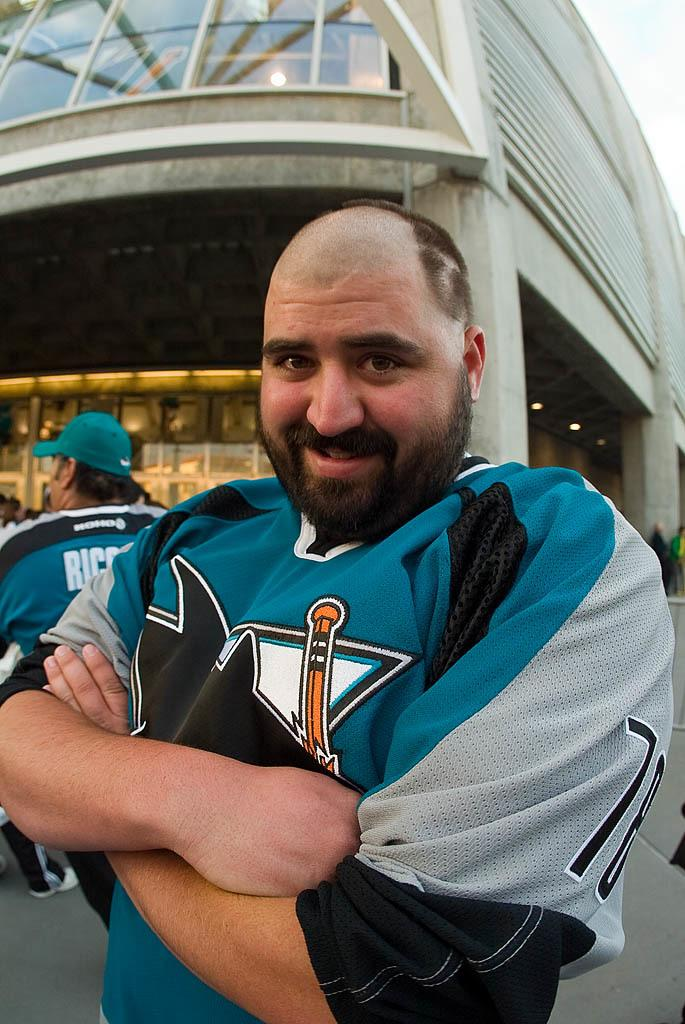<image>
Offer a succinct explanation of the picture presented. Man smiling in front of the building for a hockey game behind him is a man in a shirt that have Ric on it 